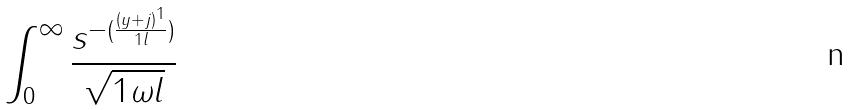Convert formula to latex. <formula><loc_0><loc_0><loc_500><loc_500>\int _ { 0 } ^ { \infty } \frac { s ^ { - ( \frac { ( y + j ) ^ { 1 } } { 1 l } ) } } { \sqrt { 1 \omega l } }</formula> 